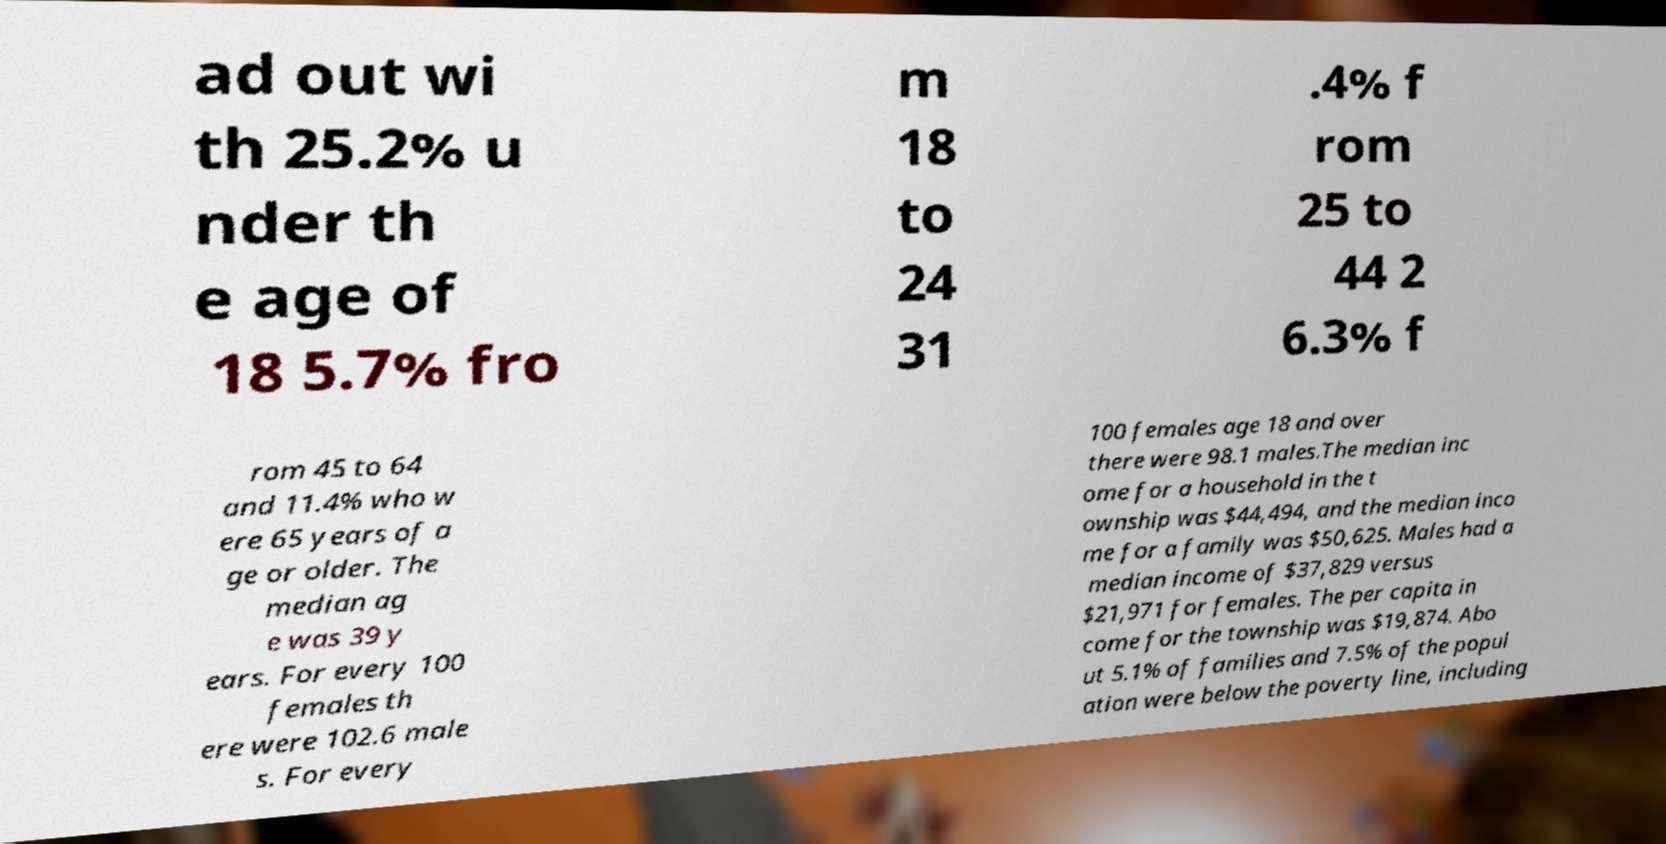There's text embedded in this image that I need extracted. Can you transcribe it verbatim? ad out wi th 25.2% u nder th e age of 18 5.7% fro m 18 to 24 31 .4% f rom 25 to 44 2 6.3% f rom 45 to 64 and 11.4% who w ere 65 years of a ge or older. The median ag e was 39 y ears. For every 100 females th ere were 102.6 male s. For every 100 females age 18 and over there were 98.1 males.The median inc ome for a household in the t ownship was $44,494, and the median inco me for a family was $50,625. Males had a median income of $37,829 versus $21,971 for females. The per capita in come for the township was $19,874. Abo ut 5.1% of families and 7.5% of the popul ation were below the poverty line, including 